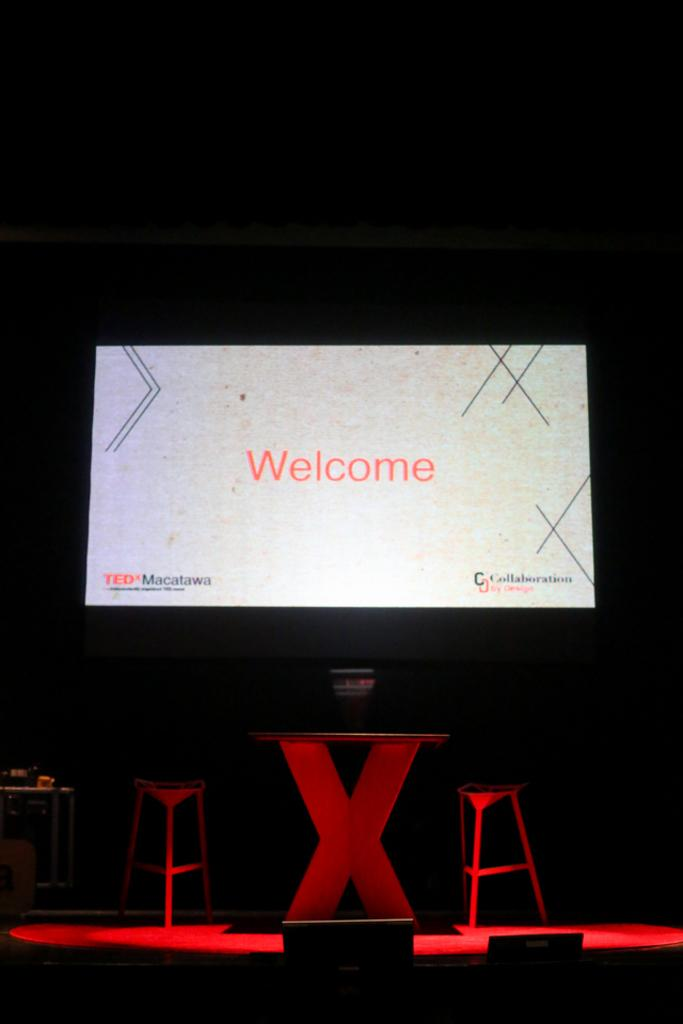<image>
Render a clear and concise summary of the photo. A table and stools in front of a screen that says Welcome with the TED talks logo. 